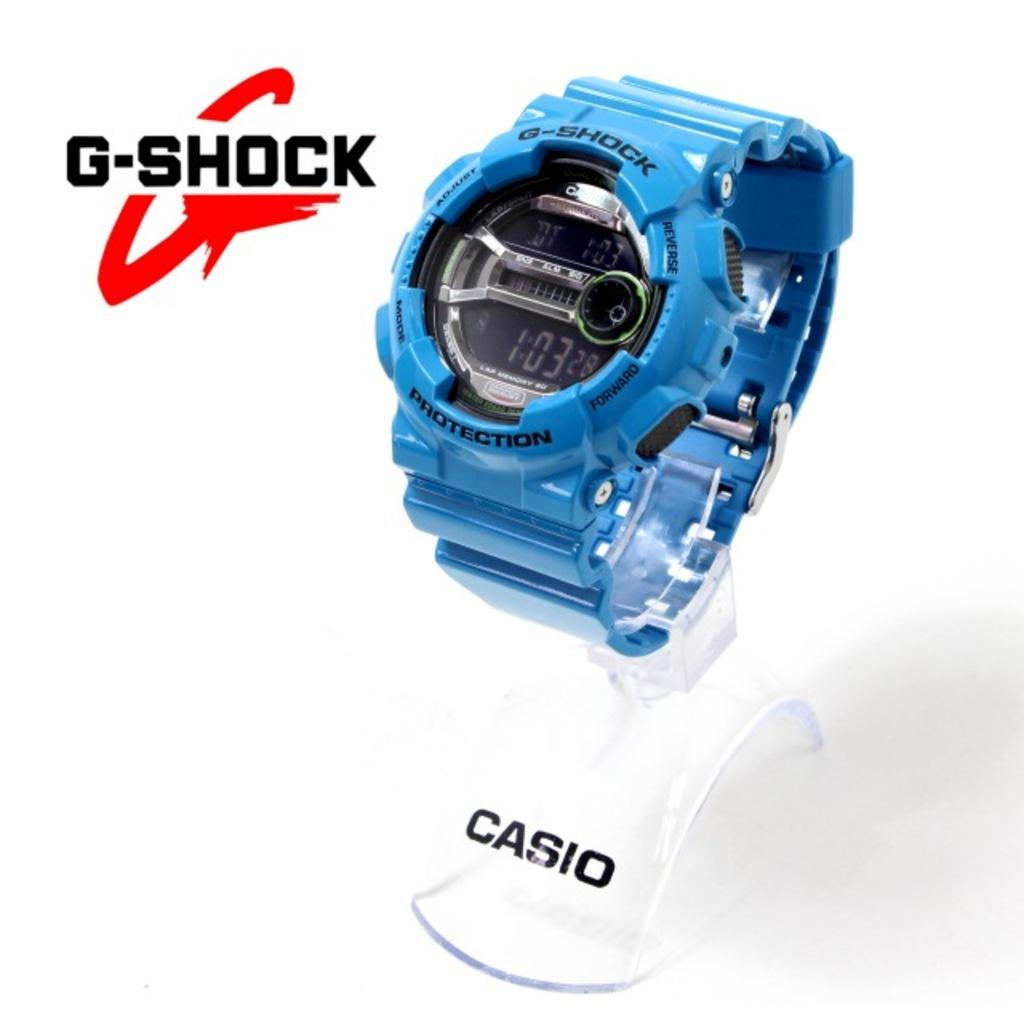<image>
Write a terse but informative summary of the picture. Casio G-Shock Watch that is protected and shows the time 1:03:28. 